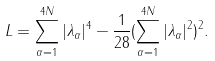<formula> <loc_0><loc_0><loc_500><loc_500>L = \sum _ { \alpha = 1 } ^ { 4 N } | \lambda _ { \alpha } | ^ { 4 } - \frac { 1 } { 2 8 } ( \sum _ { \alpha = 1 } ^ { 4 N } | \lambda _ { \alpha } | ^ { 2 } ) ^ { 2 } .</formula> 